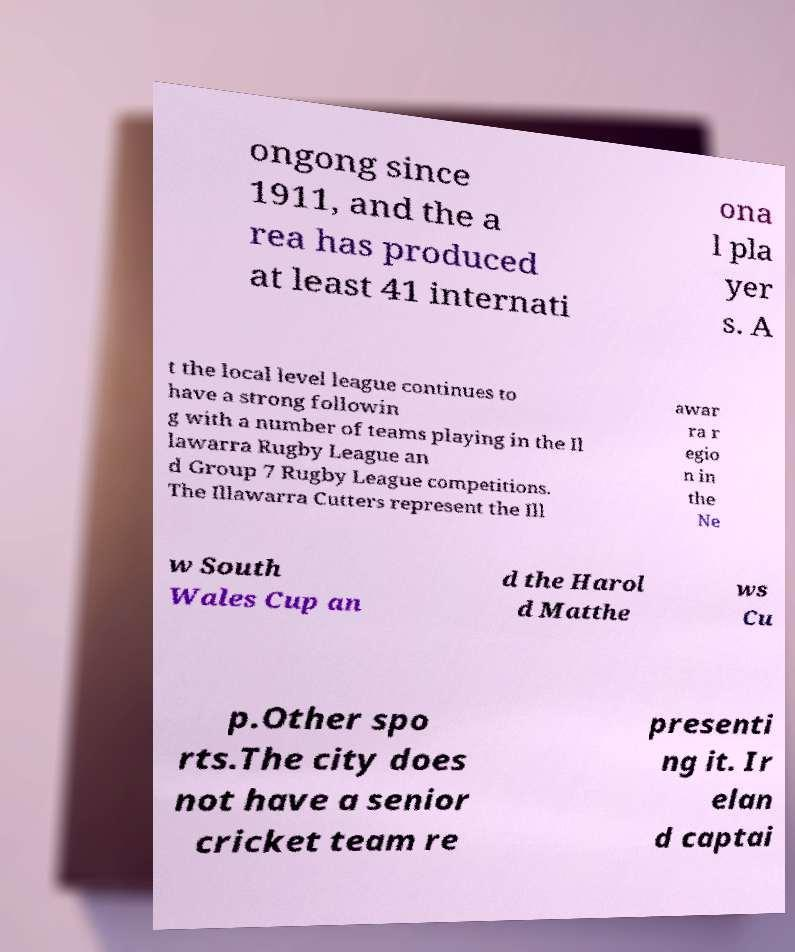There's text embedded in this image that I need extracted. Can you transcribe it verbatim? ongong since 1911, and the a rea has produced at least 41 internati ona l pla yer s. A t the local level league continues to have a strong followin g with a number of teams playing in the Il lawarra Rugby League an d Group 7 Rugby League competitions. The Illawarra Cutters represent the Ill awar ra r egio n in the Ne w South Wales Cup an d the Harol d Matthe ws Cu p.Other spo rts.The city does not have a senior cricket team re presenti ng it. Ir elan d captai 